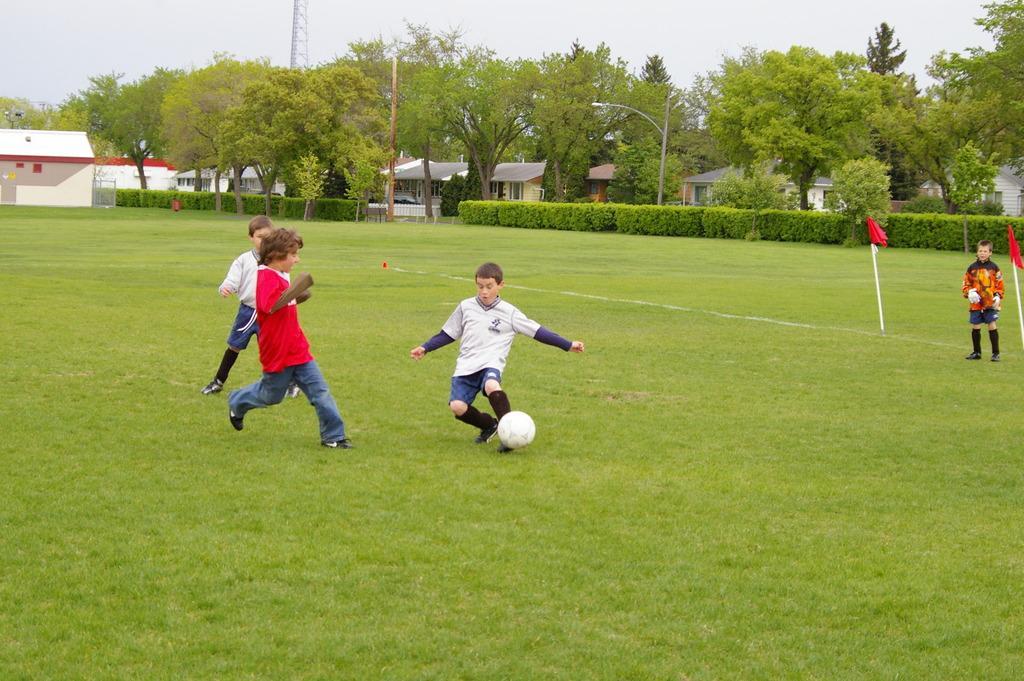Describe this image in one or two sentences. In the image there are kids playing football on grass field,On the background there are many trees and homes. 